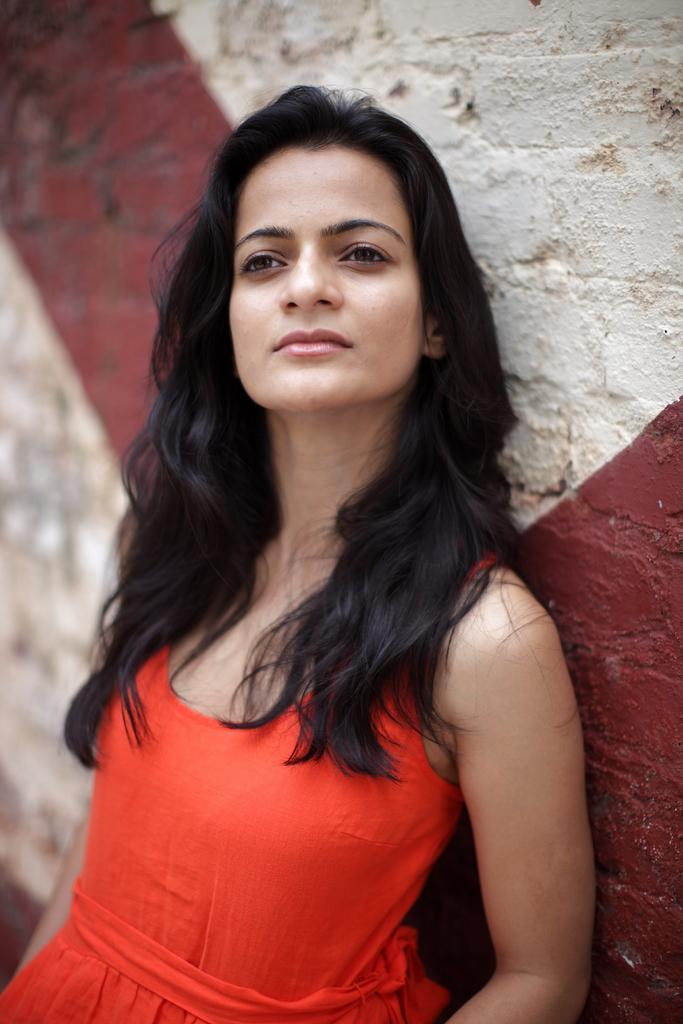Who is the main subject in the foreground of the image? There is a woman in the foreground of the image. What is the woman doing in the image? The woman is standing near a wall. What color is the dress the woman is wearing? The woman is wearing a red color dress. How many cats are sitting on the woman's head in the image? There are no cats present in the image, so it is not possible to answer that question. 